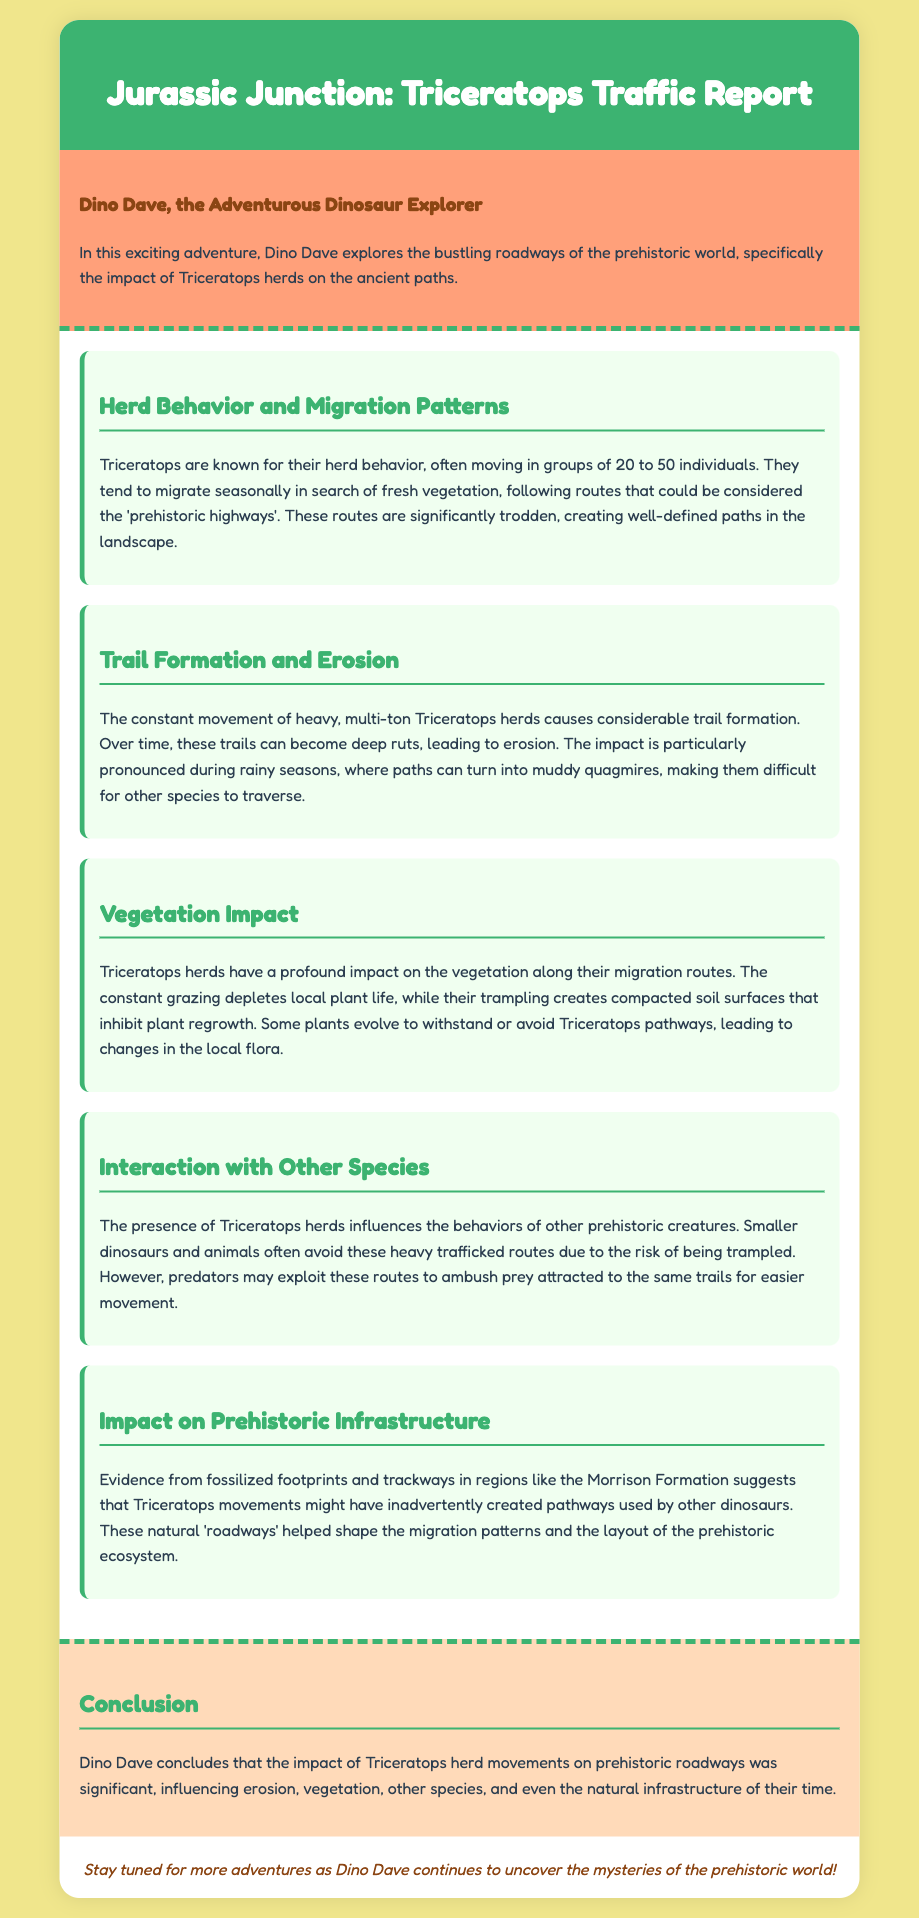What is the average size of a Triceratops herd? The document mentions that Triceratops herds often move in groups of 20 to 50 individuals.
Answer: 20 to 50 individuals What is the primary cause of trail formation? The heavy, multi-ton Triceratops herds cause considerable trail formation over time.
Answer: Constant movement of herds How does Triceratops movement affect soil? Their trampling creates compacted soil surfaces that inhibit plant regrowth.
Answer: Compacted soil surfaces What impact do Triceratops herds have on smaller dinosaurs? Smaller dinosaurs and animals often avoid heavily trafficked routes due to the risk of being trampled.
Answer: Avoid routes What evidence suggests Triceratops created natural pathways? Fossilized footprints and trackways in regions like the Morrison Formation provide evidence.
Answer: Fossilized footprints Why do some plants evolve concerning Triceratops pathways? Some plants evolve to withstand or avoid Triceratops pathways due to the constant grazing and trampling.
Answer: To withstand or avoid pathways What season exacerbates trail erosion caused by Triceratops? The impact of erosion is particularly pronounced during rainy seasons.
Answer: Rainy seasons What color is the section header for "Herd Behavior and Migration Patterns"? The section headers, including "Herd Behavior and Migration Patterns," are colored #3cb371.
Answer: #3cb371 